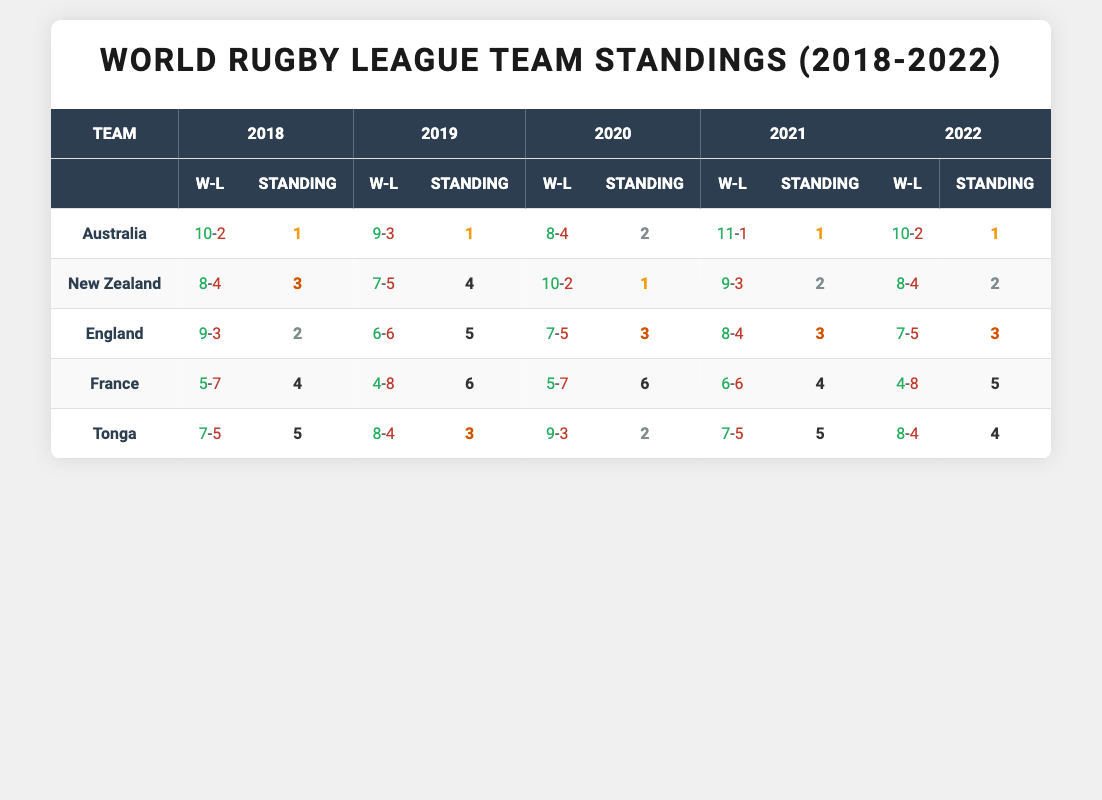What team had the best win-loss record in 2021? In 2021, Australia had a win-loss record of 11-1, which is the best record in that year compared to the other teams.
Answer: Australia How many total wins did England have from 2018 to 2022? England's wins over the years are as follows: 9 (2018) + 6 (2019) + 7 (2020) + 8 (2021) + 7 (2022) = 37 total wins.
Answer: 37 Did New Zealand ever finish in the top two standings in these five years? Yes, New Zealand finished in the top two standings three times: 1st in 2020 and 2nd in both 2021 and 2022.
Answer: Yes Which team has the most consistent top-three standings from 2018 to 2022? Australia finished in the top three standings every year: 1st in 2018, 2019, 2021, and 2022, and 2nd in 2020. This shows consistency in their performance.
Answer: Australia What was the average number of wins for Tonga over these five years? Tonga's wins are: 7 (2018), 8 (2019), 9 (2020), 7 (2021), and 8 (2022). Summing them gives 39. The average is 39/5 = 7.8.
Answer: 7.8 In what year did France have their lowest win-loss record? France had their lowest win-loss record in 2019 with 4 wins and 8 losses. This is evident as it shows the fewest wins compared to other years.
Answer: 2019 Which team's standing improved the most from 2018 to 2020? New Zealand improved dramatically from a standing of 3 in 2018 to 1 in 2020, a difference of two places, indicating a significant improvement.
Answer: New Zealand Did any team have a win-loss ratio greater than 0.85 in any year? Yes, Australia had a win-loss ratio greater than 0.85 in both 2018 (10/2 = 0.83) and 2021 (11/1 = 0.92), thus meeting the criteria in 2021.
Answer: Yes 